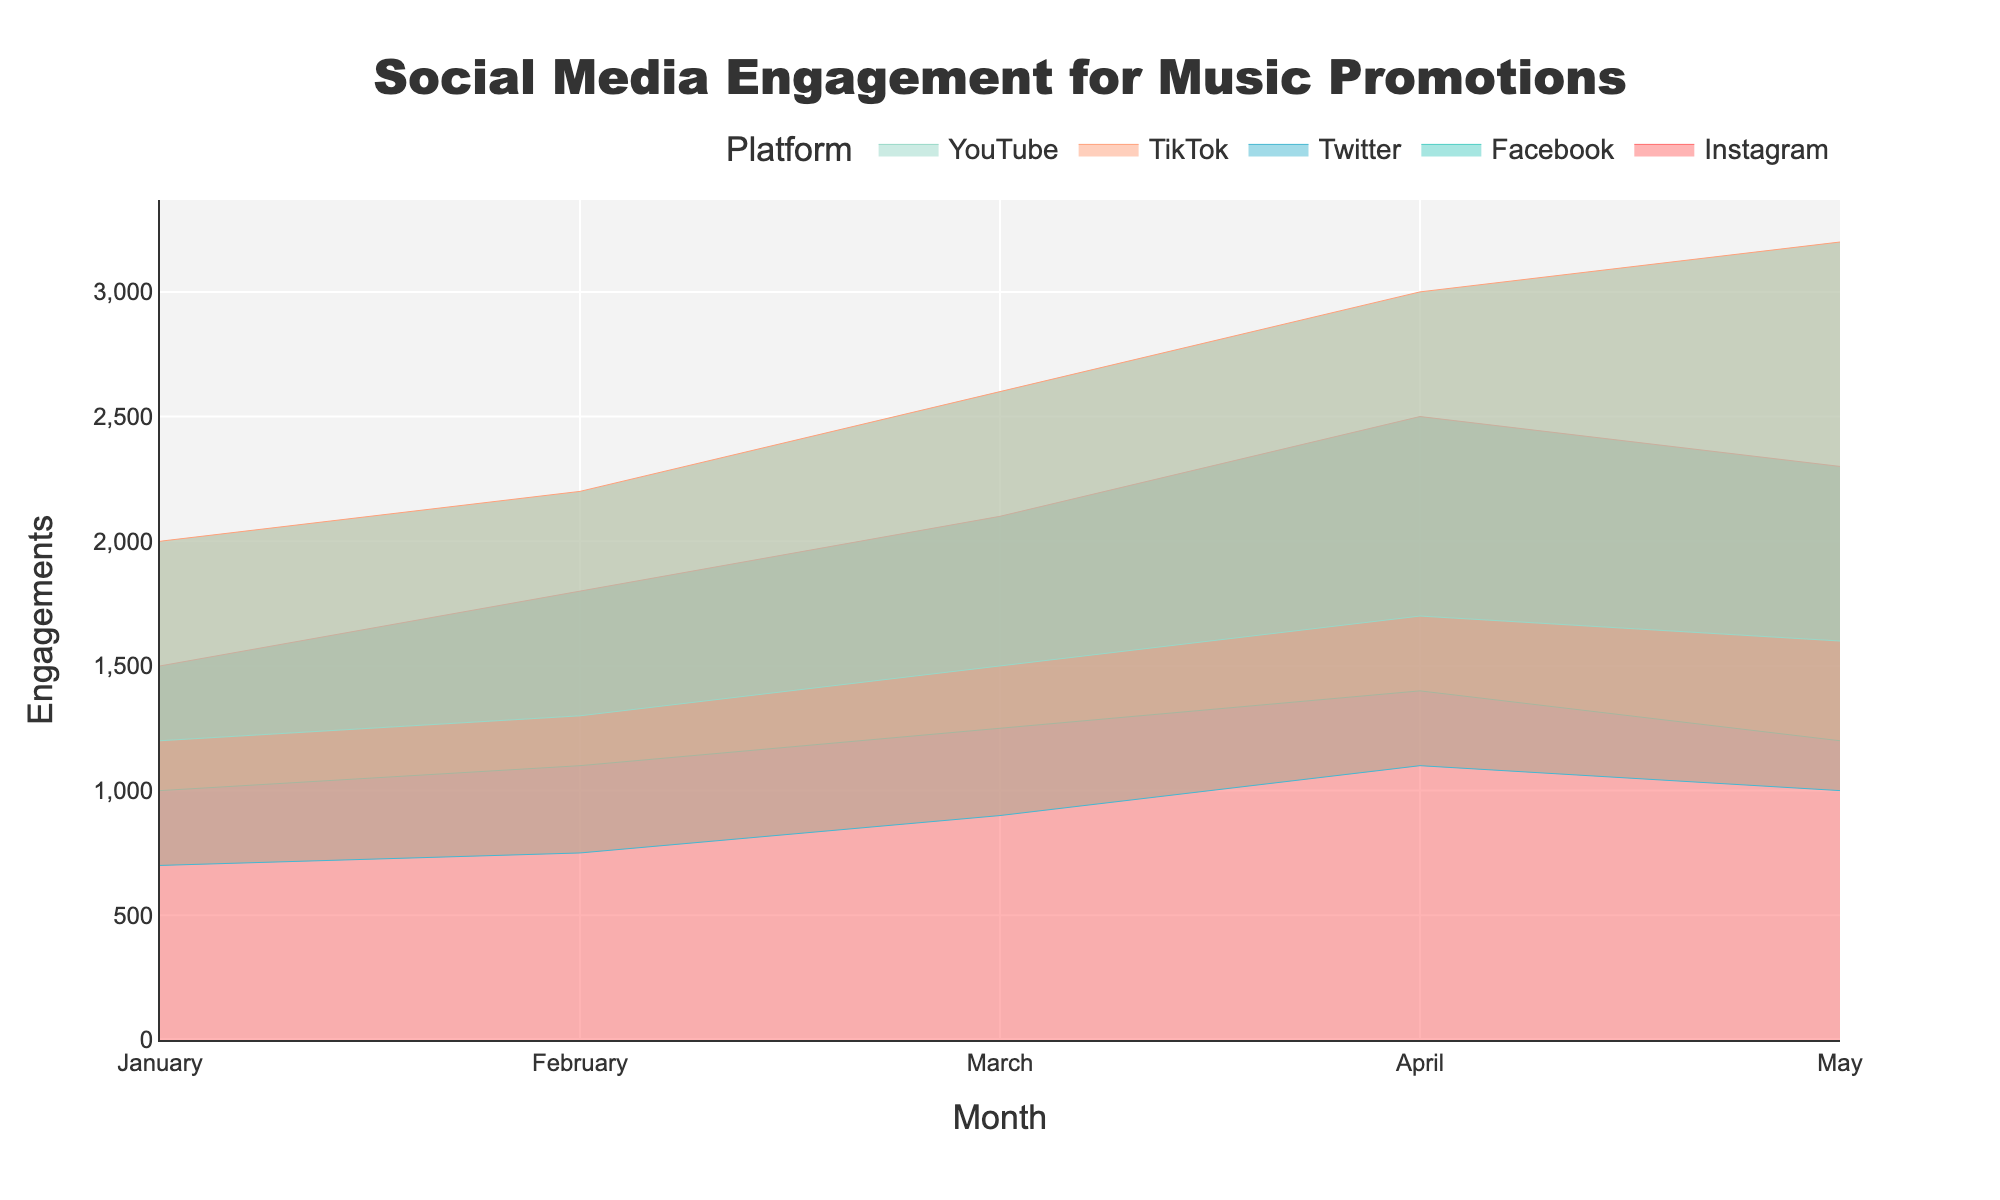What is the title of the chart? The title is located at the top center of the figure. It reads 'Social Media Engagement for Music Promotions'.
Answer: Social Media Engagement for Music Promotions Which platform had the highest engagements in April? The highest point in April is observed in the TikTok area. TikTok's engagements in April are the tallest among all platforms.
Answer: TikTok How many months are covered in the chart? The chart shows data from January to May. Counting these months gives a total of 5 months.
Answer: 5 What is the color used to represent Instagram? The color used for Instagram appears as the first one in the list of colors and is reddish (like #FF6B6B).
Answer: Reddish By how much did YouTube's engagements increase from January to April? In January, YouTube had 1200 engagements. By April, this number increased to 1700. The difference is 1700 - 1200 = 500.
Answer: 500 Which platform had the least engagement in January? The lowest point in January among all platforms is Twitter with 700 engagements.
Answer: Twitter How did Facebook's engagements change from February to March? In February, Facebook had 1100 engagements, and in March, it had 1250 engagements. Therefore, engagements increased by 1250 - 1100 = 150.
Answer: Increased by 150 What is the engagement trend for TikTok from January to May? TikTok's engagements increased consistently from 2000 in January to 2200 in February, 2600 in March, 3000 in April, and 3200 in May, showing a steady upward trend.
Answer: Steady upward trend Which platform showed the most consistent increase in engagements over the months? TikTok shows a nearly linear increase in engagements each month from January to May, indicating a consistent increase.
Answer: TikTok Compare the total engagements of Instagram and Facebook over all months. Which one had more? Sum of Instagram's engagements: 1500 + 1800 + 2100 + 2500 + 2300 = 10200. Sum of Facebook's engagements: 1000 + 1100 + 1250 + 1400 + 1200 = 5950. Instagram had more total engagements.
Answer: Instagram 